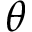Convert formula to latex. <formula><loc_0><loc_0><loc_500><loc_500>\theta</formula> 